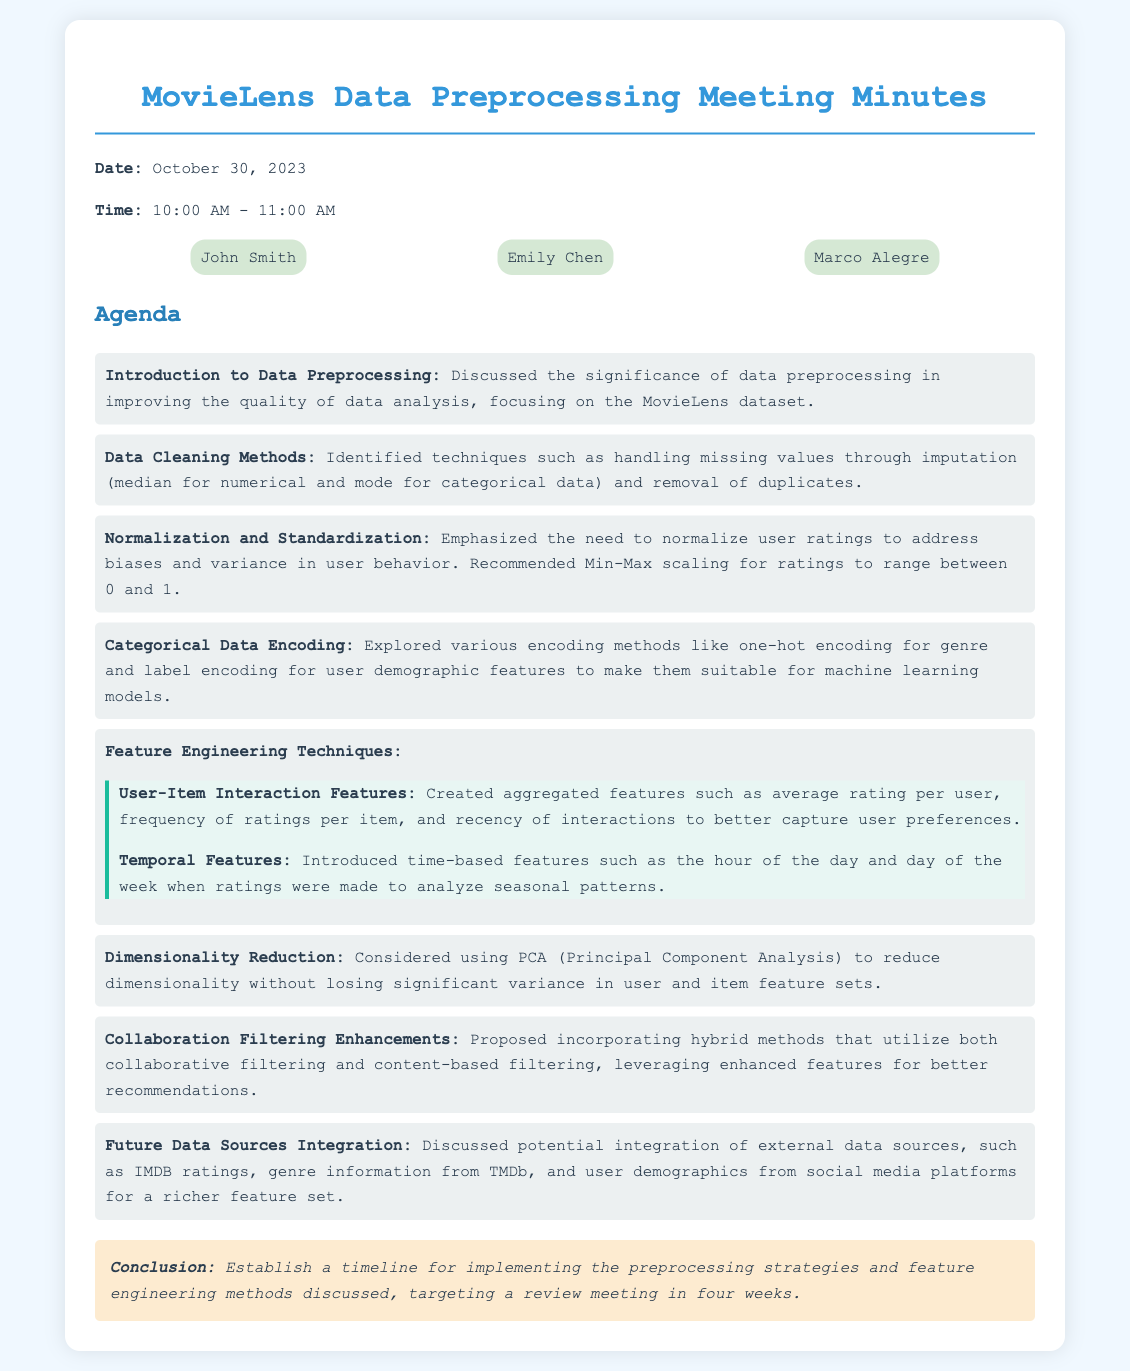what is the date of the meeting? The meeting date is stated as October 30, 2023.
Answer: October 30, 2023 who is the first participant listed? The participants section lists John Smith as the first participant.
Answer: John Smith what normalization technique was recommended for user ratings? The document emphasizes the need for Min-Max scaling for normalizing ratings.
Answer: Min-Max scaling which feature engineering technique involves temporal analysis? The temporal features section discusses time-based features introduced for analysis.
Answer: Temporal Features how many participants attended the meeting? The document lists three participants in total.
Answer: Three what was proposed to enhance collaboration filtering? The meeting minutes suggest incorporating hybrid methods for better recommendations.
Answer: Hybrid methods what type of data cleaning method was identified for handling duplicates? The document indicates the removal of duplicates as a data cleaning method.
Answer: Removal of duplicates when is the targeted review meeting planned? The conclusion states the timeline aims for a review meeting in four weeks.
Answer: Four weeks 